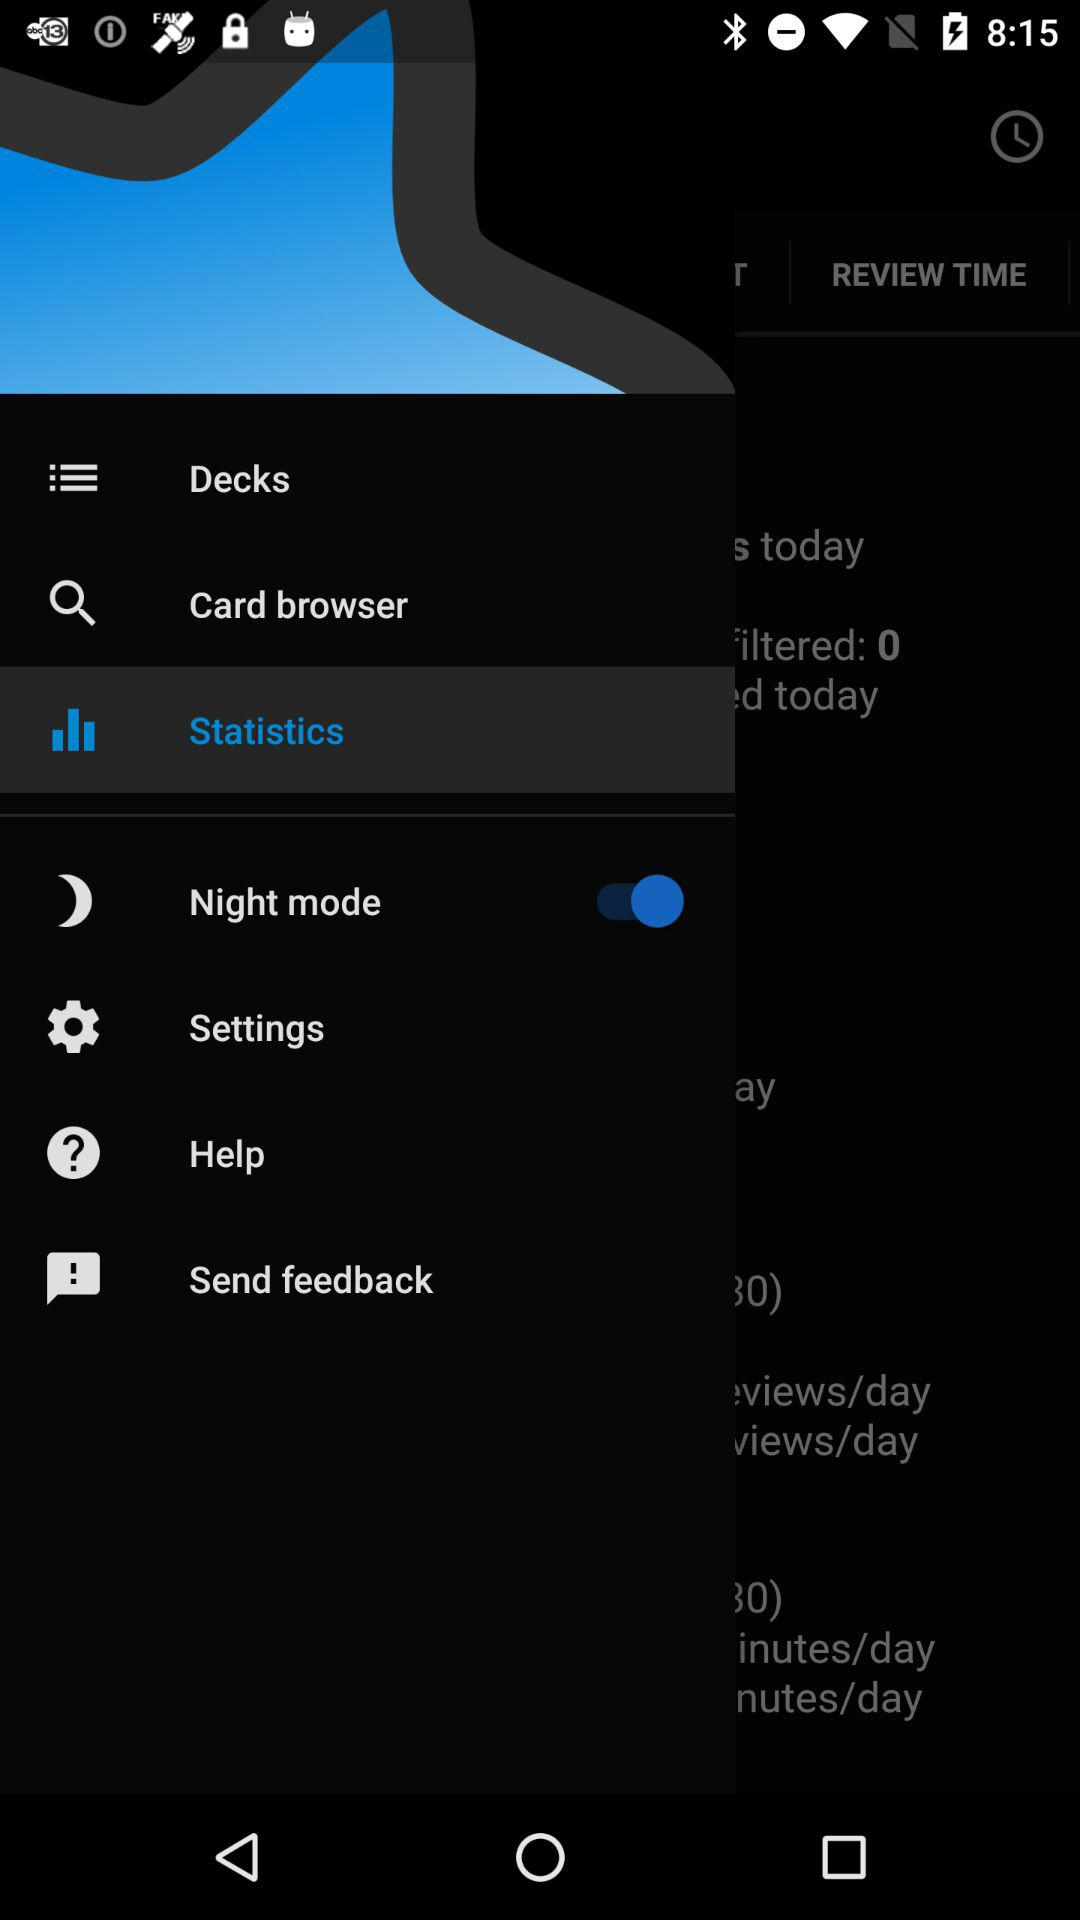What is the status of the "Night mode" setting? The status of the "Night mode" setting is "on". 